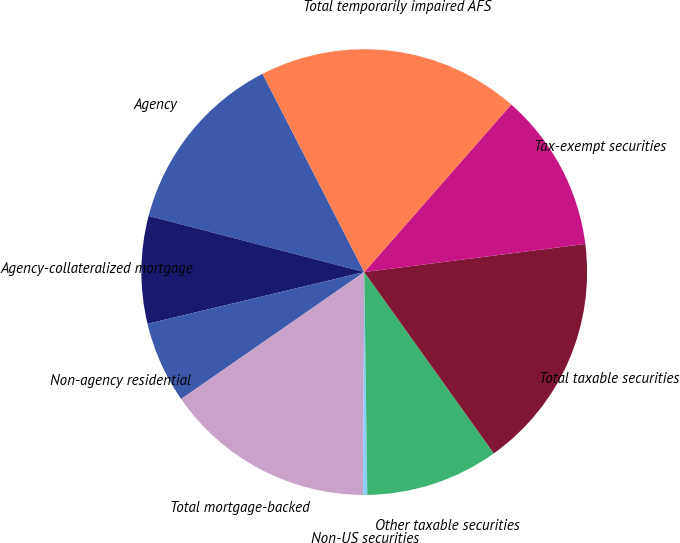Convert chart. <chart><loc_0><loc_0><loc_500><loc_500><pie_chart><fcel>Agency<fcel>Agency-collateralized mortgage<fcel>Non-agency residential<fcel>Total mortgage-backed<fcel>Non-US securities<fcel>Other taxable securities<fcel>Total taxable securities<fcel>Tax-exempt securities<fcel>Total temporarily impaired AFS<nl><fcel>13.4%<fcel>7.79%<fcel>5.92%<fcel>15.27%<fcel>0.3%<fcel>9.66%<fcel>17.14%<fcel>11.53%<fcel>19.01%<nl></chart> 